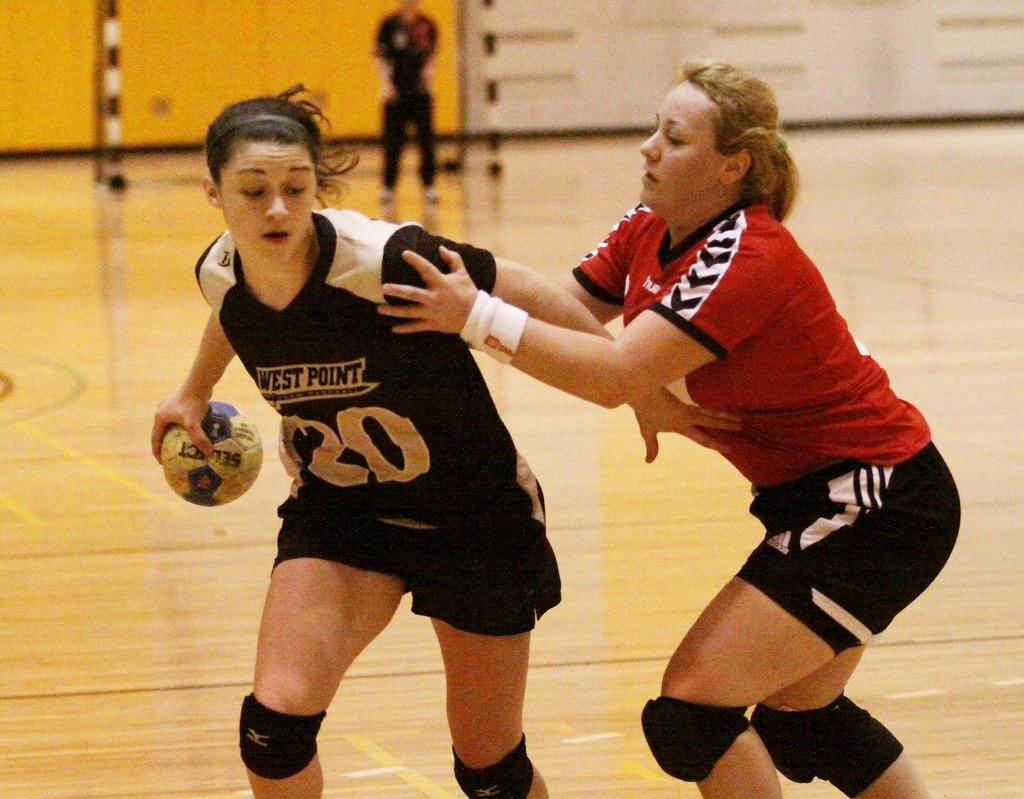How many women are in the image? There are two women in the image. What is one of the women holding in her hand? One of the women is holding a ball in her hand. What can be seen in the background of the image? In the background, there is a person standing on the ground, a wall, and some objects. What type of bait is the crow using to catch fish in the image? There is no crow or fishing activity present in the image. 